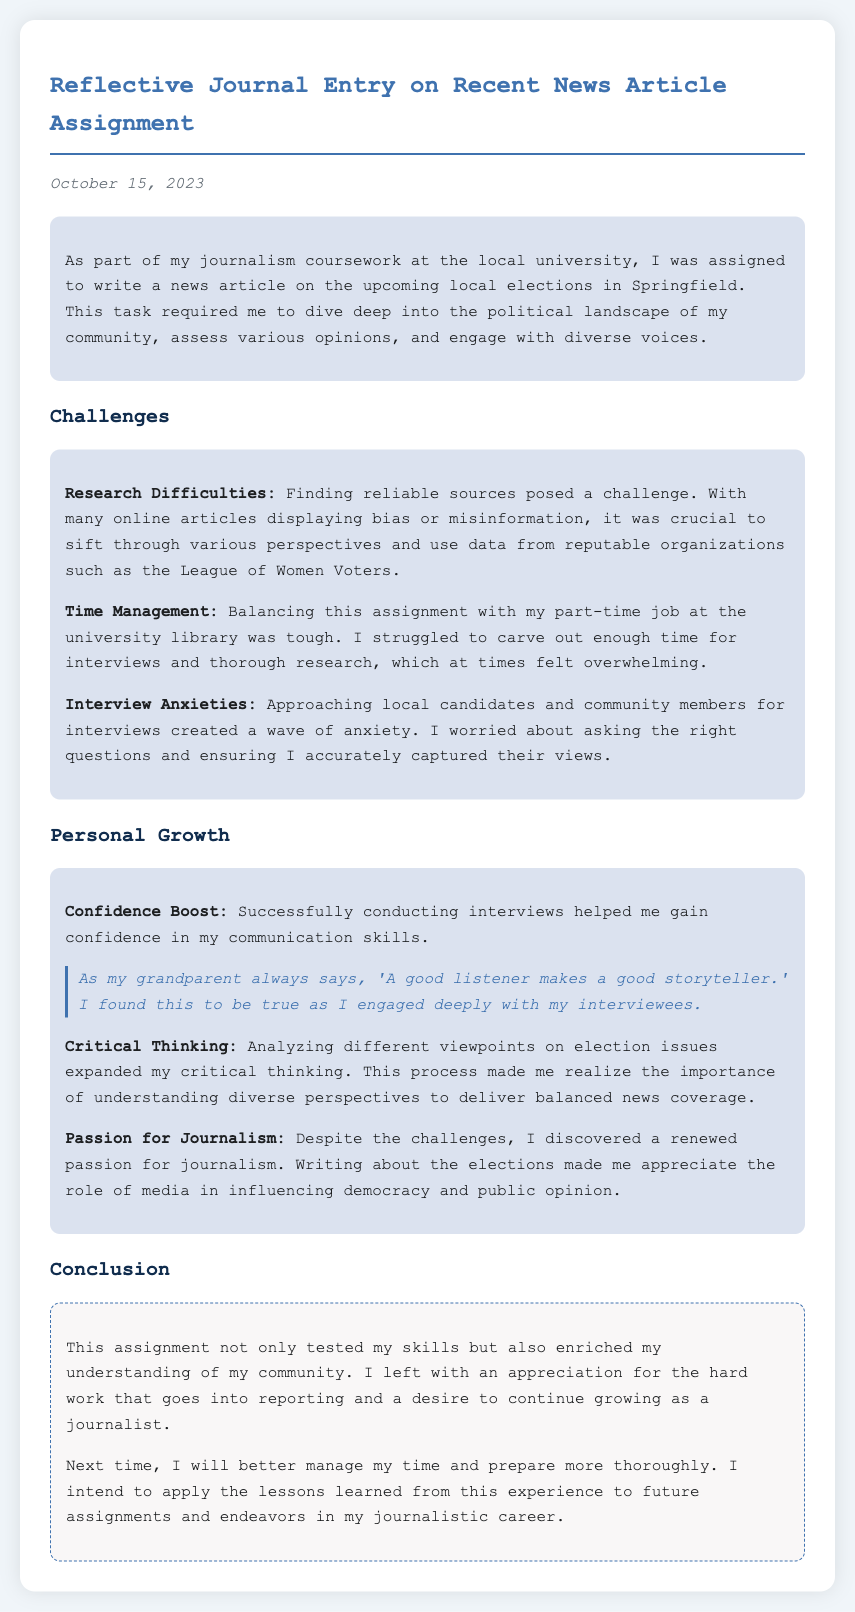What was the date of the journal entry? The date mentioned in the document is when the reflective journal entry was created.
Answer: October 15, 2023 What topic was the news article about? The journal entry specifies the focus of the assignment which is related to a specific local event.
Answer: Local elections What was one challenge faced during the assignment? The document lists various challenges encountered during the article-writing process.
Answer: Research difficulties Who is quoted regarding the importance of listening? The quote provided in the personal growth section references someone that the author admires.
Answer: Grandparent What did the author discover about their passion for journalism? The entry reflects on the personal feelings towards journalism after completing the assignment.
Answer: Renewed passion What was the author’s part-time job? The journal mentions part-time work in an area that might have contributed to time management issues.
Answer: University library What skill did conducting interviews boost for the author? The author reflects on personal growth and the specific skills improved through the interviews.
Answer: Communication skills What was one lesson the author intends to apply to future assignments? The conclusion section emphasizes what the author learned through the experience that can improve future work.
Answer: Better manage time 